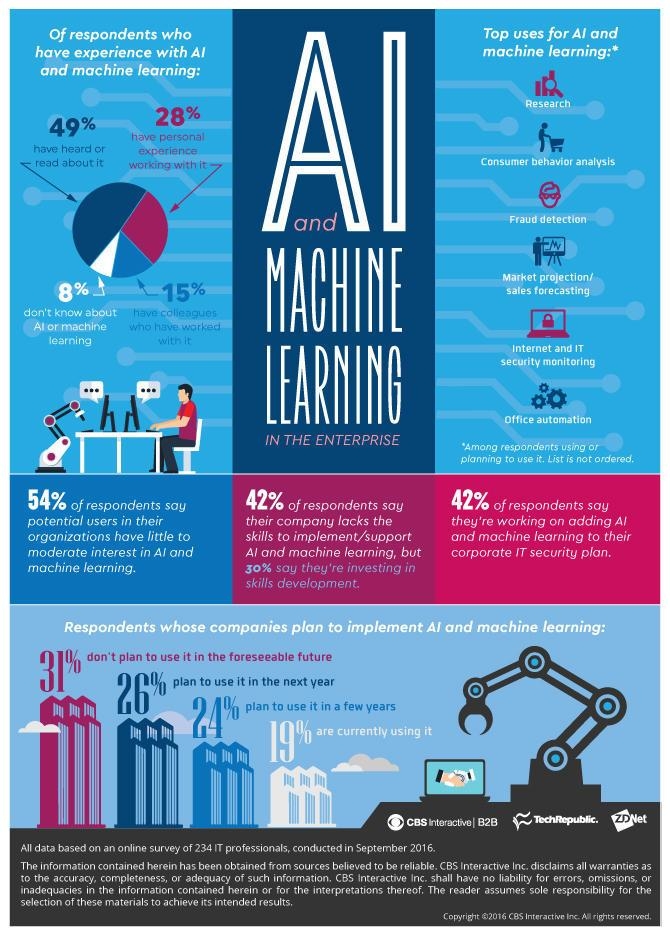List a handful of essential elements in this visual. According to a survey conducted in September 2016, 26% of respondents reported that their companies plan to use AI & machine learning in the next year. According to a survey conducted in September 2016, 19% of respondents revealed that their companies were currently utilizing AI and machine learning technology. According to the survey conducted in September 2016, 28% of respondents reported having personal experience working with AI & machine learning. Eight percent of respondents in a survey conducted in September 2016 were unsure about AI & machine learning, according to the survey results. 